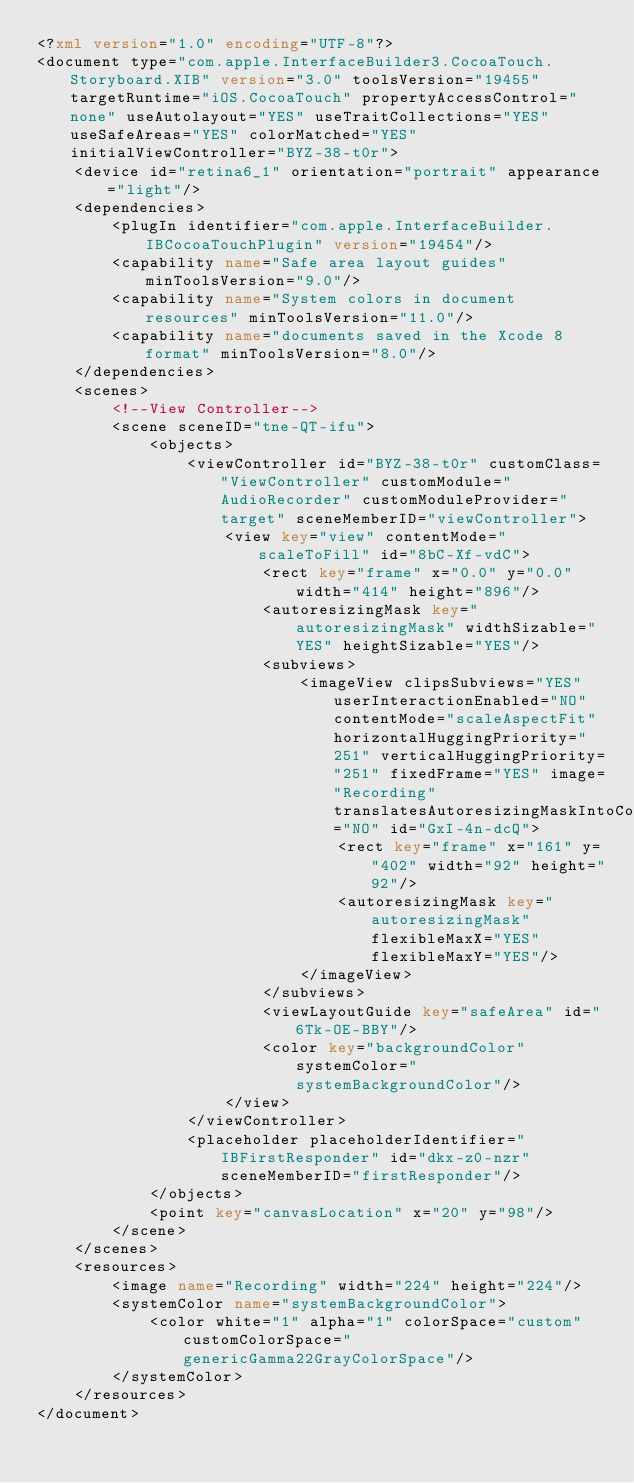Convert code to text. <code><loc_0><loc_0><loc_500><loc_500><_XML_><?xml version="1.0" encoding="UTF-8"?>
<document type="com.apple.InterfaceBuilder3.CocoaTouch.Storyboard.XIB" version="3.0" toolsVersion="19455" targetRuntime="iOS.CocoaTouch" propertyAccessControl="none" useAutolayout="YES" useTraitCollections="YES" useSafeAreas="YES" colorMatched="YES" initialViewController="BYZ-38-t0r">
    <device id="retina6_1" orientation="portrait" appearance="light"/>
    <dependencies>
        <plugIn identifier="com.apple.InterfaceBuilder.IBCocoaTouchPlugin" version="19454"/>
        <capability name="Safe area layout guides" minToolsVersion="9.0"/>
        <capability name="System colors in document resources" minToolsVersion="11.0"/>
        <capability name="documents saved in the Xcode 8 format" minToolsVersion="8.0"/>
    </dependencies>
    <scenes>
        <!--View Controller-->
        <scene sceneID="tne-QT-ifu">
            <objects>
                <viewController id="BYZ-38-t0r" customClass="ViewController" customModule="AudioRecorder" customModuleProvider="target" sceneMemberID="viewController">
                    <view key="view" contentMode="scaleToFill" id="8bC-Xf-vdC">
                        <rect key="frame" x="0.0" y="0.0" width="414" height="896"/>
                        <autoresizingMask key="autoresizingMask" widthSizable="YES" heightSizable="YES"/>
                        <subviews>
                            <imageView clipsSubviews="YES" userInteractionEnabled="NO" contentMode="scaleAspectFit" horizontalHuggingPriority="251" verticalHuggingPriority="251" fixedFrame="YES" image="Recording" translatesAutoresizingMaskIntoConstraints="NO" id="GxI-4n-dcQ">
                                <rect key="frame" x="161" y="402" width="92" height="92"/>
                                <autoresizingMask key="autoresizingMask" flexibleMaxX="YES" flexibleMaxY="YES"/>
                            </imageView>
                        </subviews>
                        <viewLayoutGuide key="safeArea" id="6Tk-OE-BBY"/>
                        <color key="backgroundColor" systemColor="systemBackgroundColor"/>
                    </view>
                </viewController>
                <placeholder placeholderIdentifier="IBFirstResponder" id="dkx-z0-nzr" sceneMemberID="firstResponder"/>
            </objects>
            <point key="canvasLocation" x="20" y="98"/>
        </scene>
    </scenes>
    <resources>
        <image name="Recording" width="224" height="224"/>
        <systemColor name="systemBackgroundColor">
            <color white="1" alpha="1" colorSpace="custom" customColorSpace="genericGamma22GrayColorSpace"/>
        </systemColor>
    </resources>
</document>
</code> 